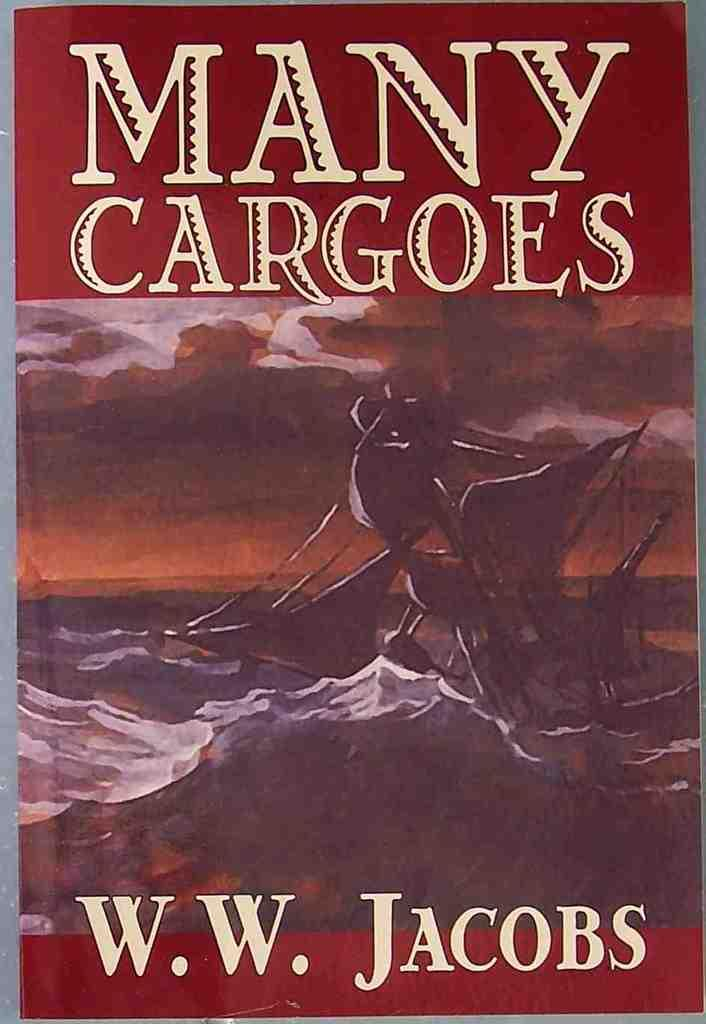What is present on the poster in the image? There is a poster in the image. What can be seen on the poster besides the poster itself? The poster has text written on it. How many men are depicted on the poster? There is no information about men on the poster, as the facts only mention the presence of text on the poster. 